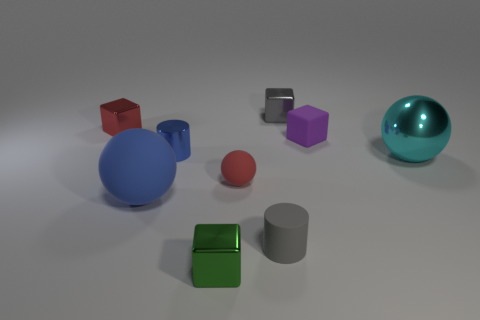What is the purple block made of?
Keep it short and to the point. Rubber. What color is the big object that is made of the same material as the purple cube?
Provide a short and direct response. Blue. Does the green block have the same material as the large sphere on the right side of the gray matte cylinder?
Offer a terse response. Yes. What number of tiny things have the same material as the small red sphere?
Provide a succinct answer. 2. There is a red object that is in front of the small blue metallic object; what shape is it?
Offer a terse response. Sphere. Is the material of the small cylinder in front of the tiny blue shiny thing the same as the big ball right of the large blue matte thing?
Your response must be concise. No. Is there a yellow object that has the same shape as the tiny gray rubber object?
Provide a short and direct response. No. What number of things are large objects that are left of the small green metal object or small red matte things?
Make the answer very short. 2. Are there more small purple blocks that are in front of the green thing than gray metallic cubes in front of the tiny red metal cube?
Provide a succinct answer. No. What number of rubber objects are big purple cylinders or purple objects?
Provide a succinct answer. 1. 